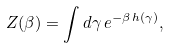<formula> <loc_0><loc_0><loc_500><loc_500>Z ( \beta ) = \int d \gamma \, e ^ { - \beta \, h ( \gamma ) } ,</formula> 